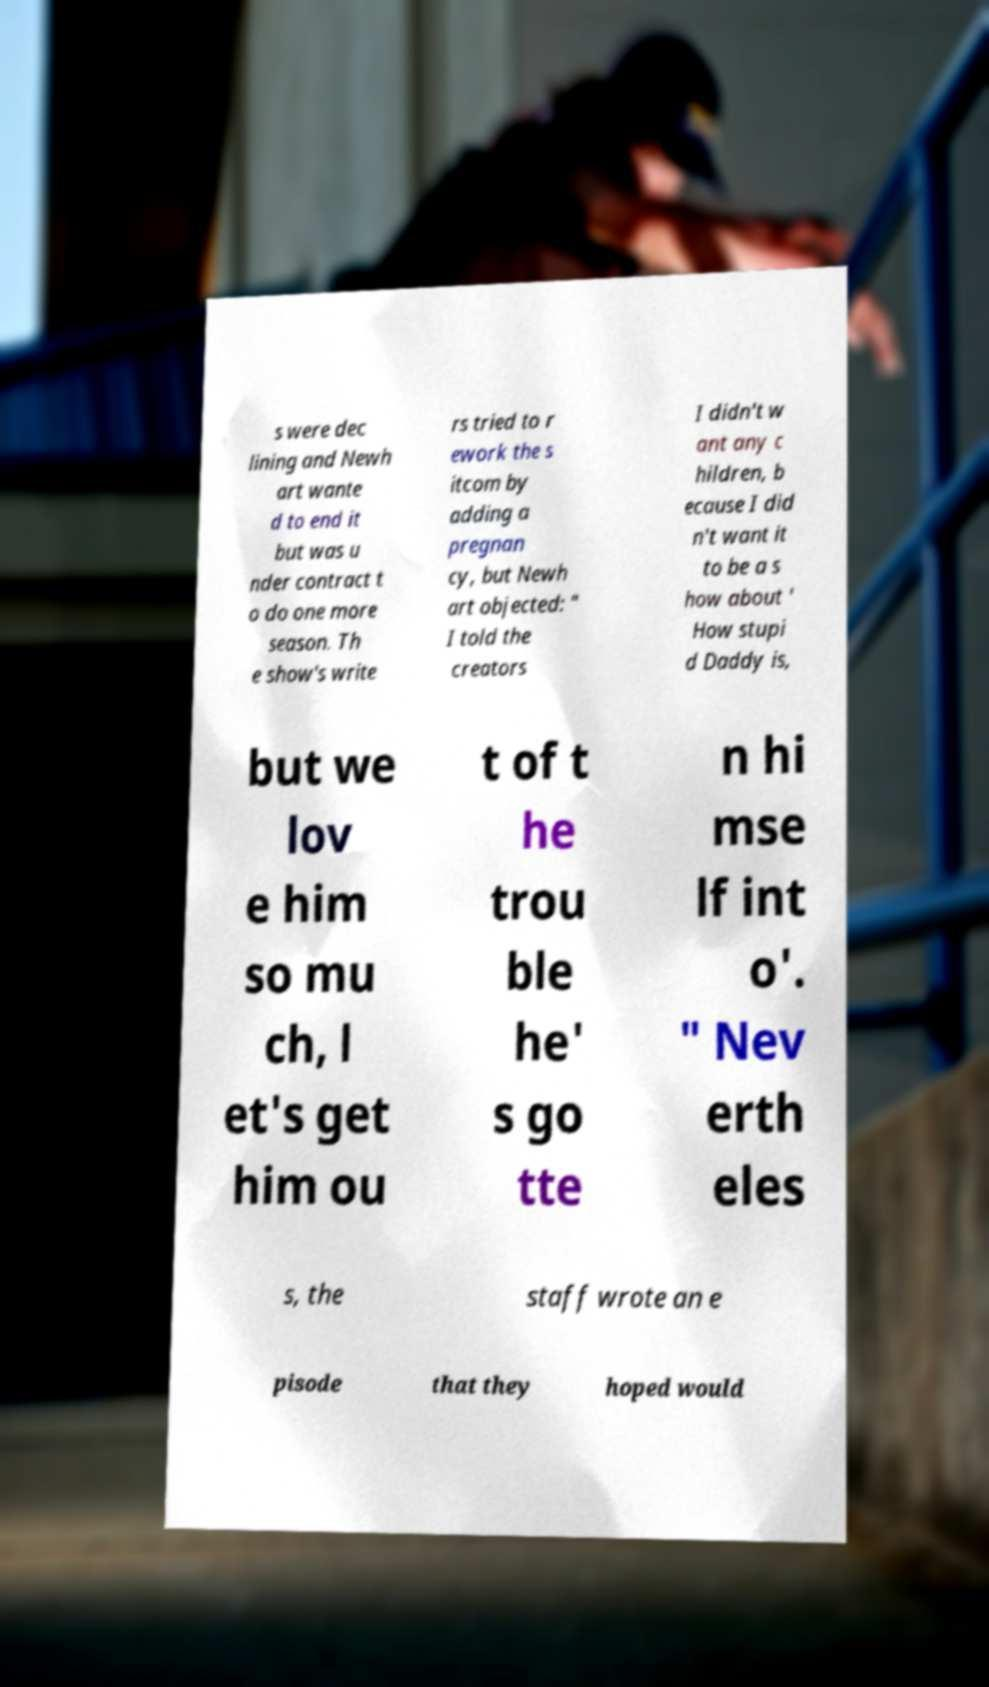For documentation purposes, I need the text within this image transcribed. Could you provide that? s were dec lining and Newh art wante d to end it but was u nder contract t o do one more season. Th e show's write rs tried to r ework the s itcom by adding a pregnan cy, but Newh art objected: " I told the creators I didn't w ant any c hildren, b ecause I did n't want it to be a s how about ' How stupi d Daddy is, but we lov e him so mu ch, l et's get him ou t of t he trou ble he' s go tte n hi mse lf int o'. " Nev erth eles s, the staff wrote an e pisode that they hoped would 